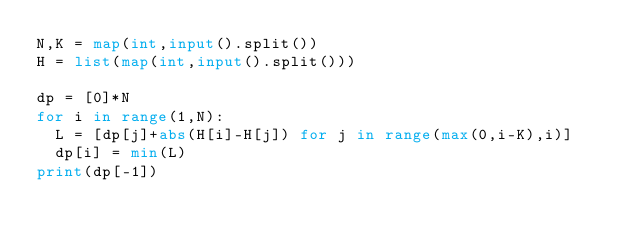<code> <loc_0><loc_0><loc_500><loc_500><_Python_>N,K = map(int,input().split())
H = list(map(int,input().split()))
 
dp = [0]*N
for i in range(1,N):
	L = [dp[j]+abs(H[i]-H[j]) for j in range(max(0,i-K),i)]
	dp[i] = min(L)
print(dp[-1])
</code> 